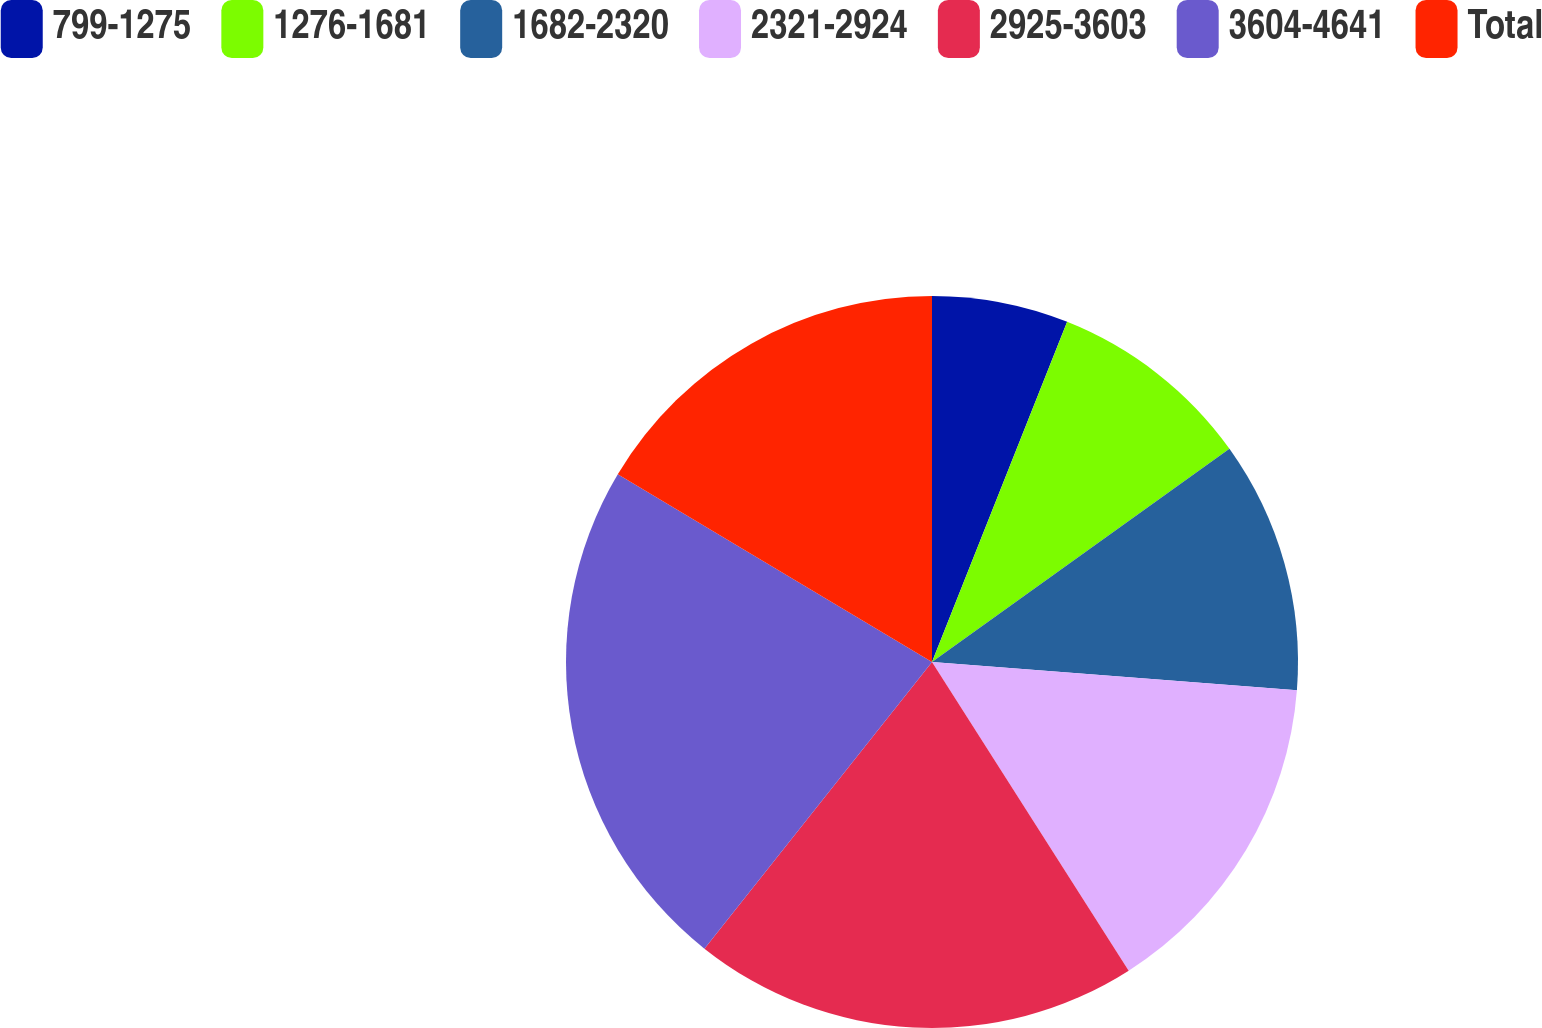Convert chart to OTSL. <chart><loc_0><loc_0><loc_500><loc_500><pie_chart><fcel>799-1275<fcel>1276-1681<fcel>1682-2320<fcel>2321-2924<fcel>2925-3603<fcel>3604-4641<fcel>Total<nl><fcel>6.02%<fcel>9.08%<fcel>11.13%<fcel>14.74%<fcel>19.71%<fcel>22.89%<fcel>16.43%<nl></chart> 